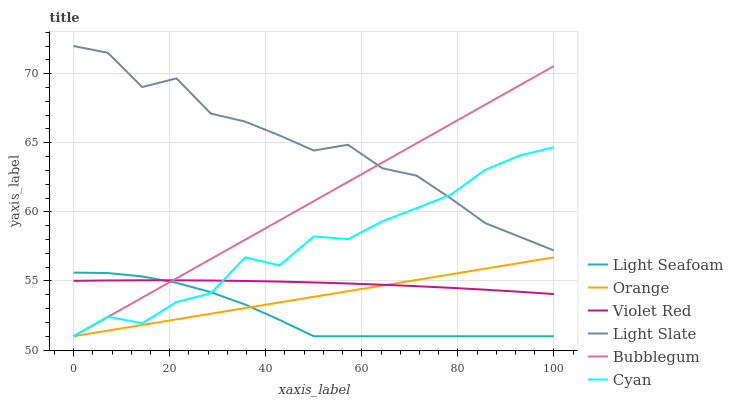Does Light Seafoam have the minimum area under the curve?
Answer yes or no. Yes. Does Light Slate have the maximum area under the curve?
Answer yes or no. Yes. Does Bubblegum have the minimum area under the curve?
Answer yes or no. No. Does Bubblegum have the maximum area under the curve?
Answer yes or no. No. Is Orange the smoothest?
Answer yes or no. Yes. Is Cyan the roughest?
Answer yes or no. Yes. Is Light Slate the smoothest?
Answer yes or no. No. Is Light Slate the roughest?
Answer yes or no. No. Does Bubblegum have the lowest value?
Answer yes or no. Yes. Does Light Slate have the lowest value?
Answer yes or no. No. Does Light Slate have the highest value?
Answer yes or no. Yes. Does Bubblegum have the highest value?
Answer yes or no. No. Is Light Seafoam less than Light Slate?
Answer yes or no. Yes. Is Light Slate greater than Orange?
Answer yes or no. Yes. Does Light Seafoam intersect Violet Red?
Answer yes or no. Yes. Is Light Seafoam less than Violet Red?
Answer yes or no. No. Is Light Seafoam greater than Violet Red?
Answer yes or no. No. Does Light Seafoam intersect Light Slate?
Answer yes or no. No. 